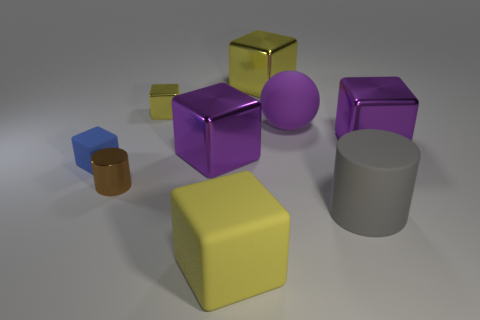How many metallic objects are purple spheres or small green objects?
Give a very brief answer. 0. What number of big objects are on the right side of the gray rubber cylinder and in front of the tiny cylinder?
Your answer should be compact. 0. Is there anything else that is the same shape as the yellow matte thing?
Ensure brevity in your answer.  Yes. How many other objects are the same size as the gray cylinder?
Offer a terse response. 5. Does the rubber object that is behind the tiny blue matte cube have the same size as the cylinder that is left of the tiny yellow thing?
Your response must be concise. No. What number of objects are either big matte blocks or metallic objects that are behind the blue matte thing?
Offer a terse response. 5. There is a purple cube to the left of the gray rubber thing; what is its size?
Your answer should be very brief. Large. Is the number of gray objects that are on the right side of the small blue matte thing less than the number of yellow matte objects that are behind the small yellow cube?
Your answer should be compact. No. There is a big thing that is both left of the big gray cylinder and in front of the small matte thing; what material is it?
Ensure brevity in your answer.  Rubber. The small metal thing behind the purple metal thing that is on the right side of the large rubber cylinder is what shape?
Ensure brevity in your answer.  Cube. 